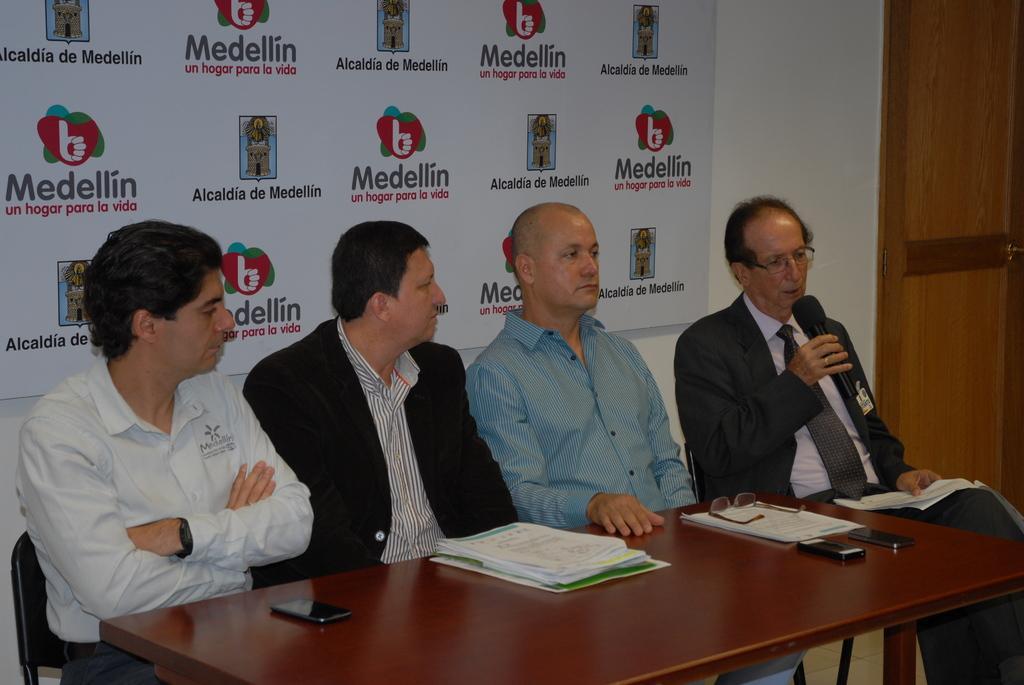Describe this image in one or two sentences. In this picture there are four men who are sitting on the chair near to the table. On the table I can see the mobile phones, papers, files and other objects. Right person is holding a mic. Behind them I can see the banner which is placed on the wall. On the right I can see the door. 